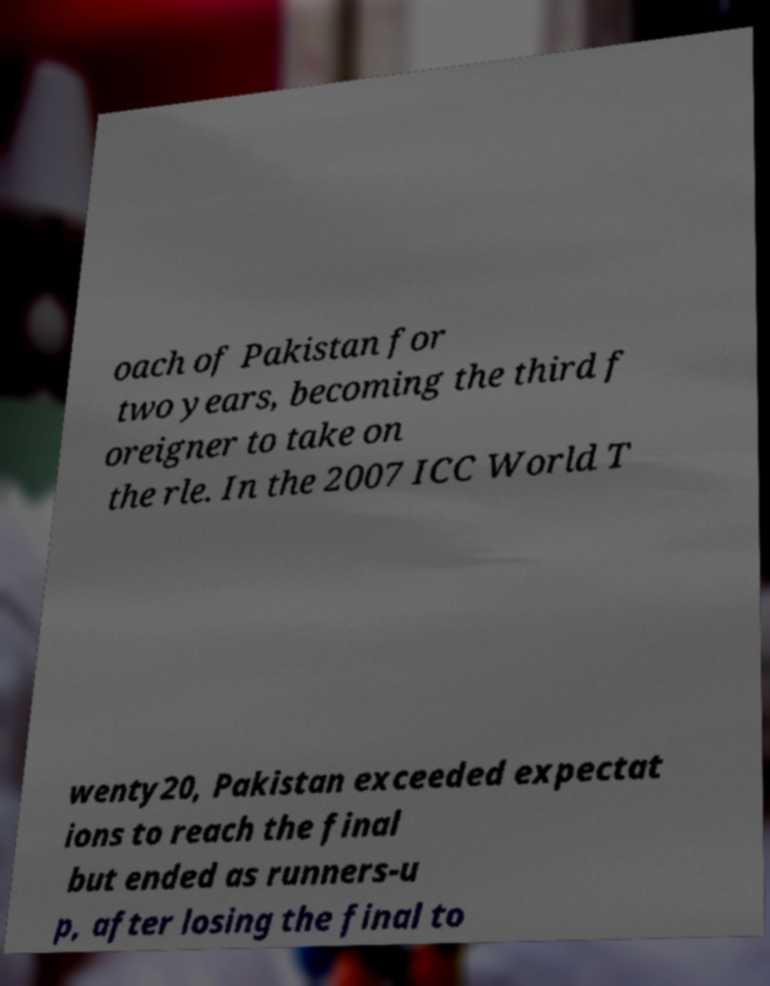Please identify and transcribe the text found in this image. oach of Pakistan for two years, becoming the third f oreigner to take on the rle. In the 2007 ICC World T wenty20, Pakistan exceeded expectat ions to reach the final but ended as runners-u p, after losing the final to 